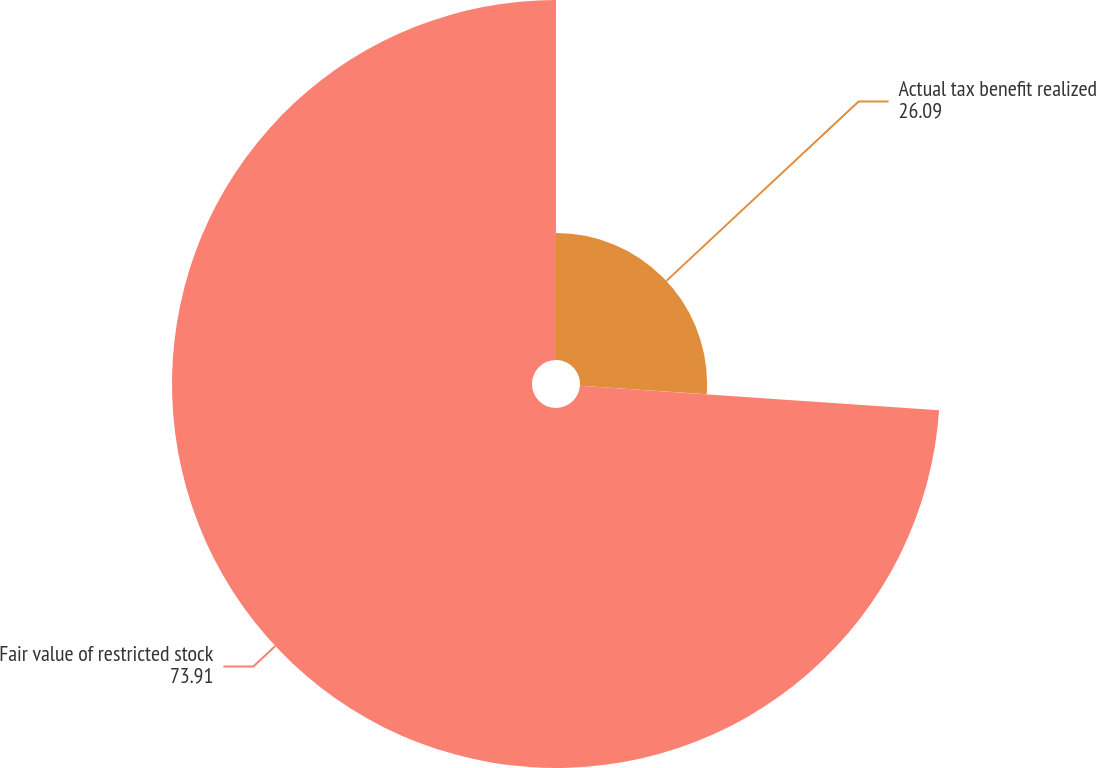Convert chart. <chart><loc_0><loc_0><loc_500><loc_500><pie_chart><fcel>Actual tax benefit realized<fcel>Fair value of restricted stock<nl><fcel>26.09%<fcel>73.91%<nl></chart> 